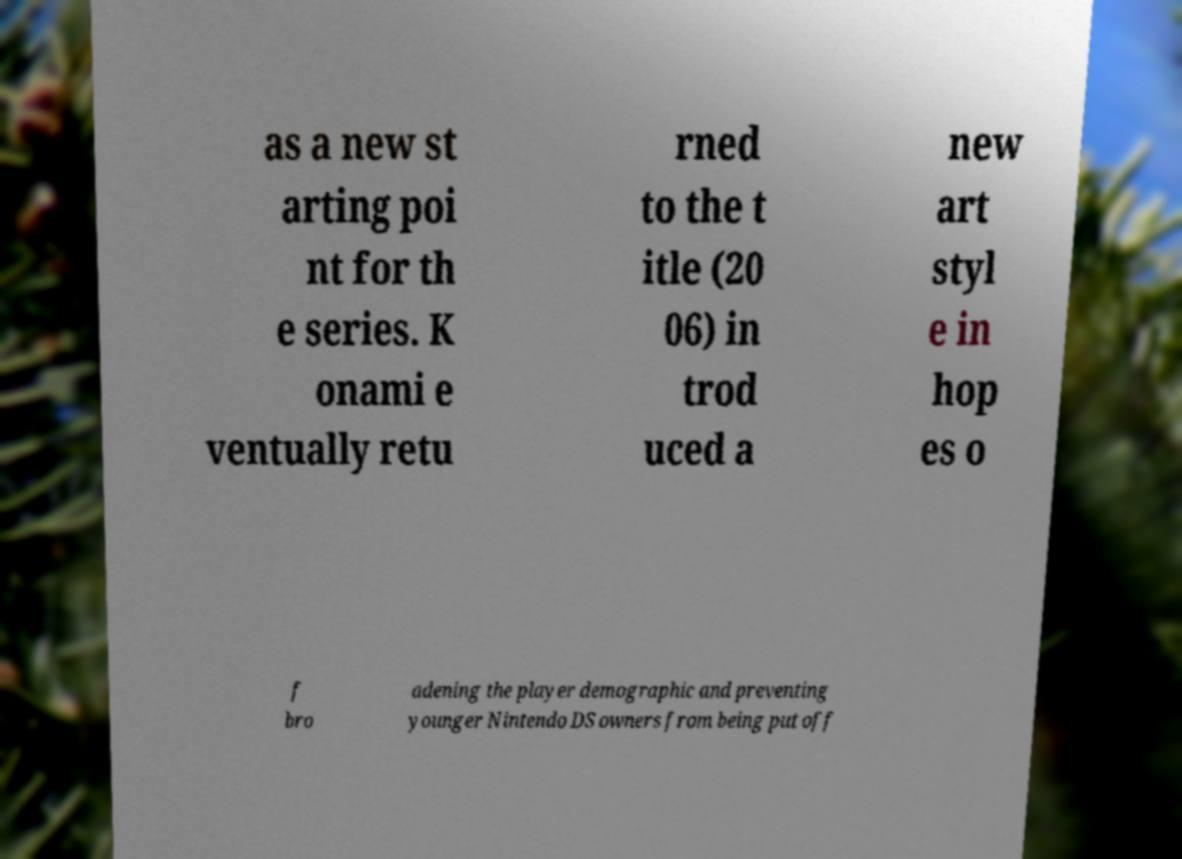Can you accurately transcribe the text from the provided image for me? as a new st arting poi nt for th e series. K onami e ventually retu rned to the t itle (20 06) in trod uced a new art styl e in hop es o f bro adening the player demographic and preventing younger Nintendo DS owners from being put off 